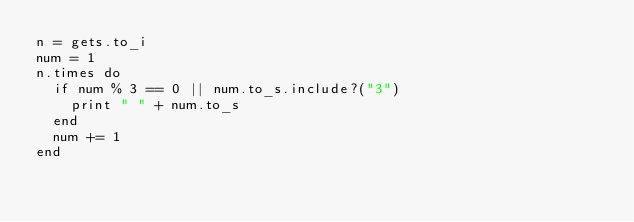<code> <loc_0><loc_0><loc_500><loc_500><_Ruby_>n = gets.to_i
num = 1
n.times do
  if num % 3 == 0 || num.to_s.include?("3")
    print " " + num.to_s
  end
  num += 1
end
</code> 